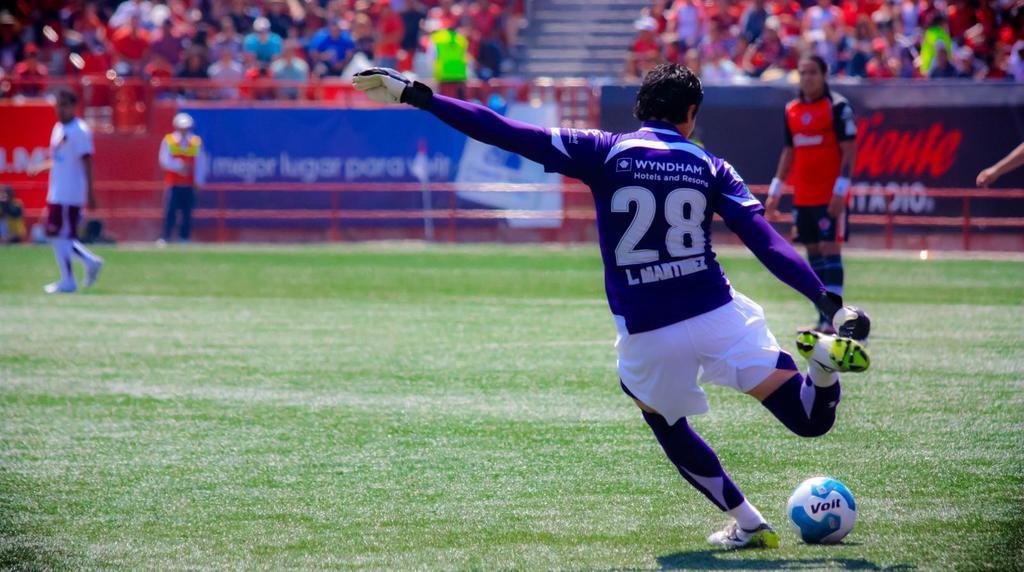Please provide a concise description of this image. In this image I see 3 men who are wearing jerseys and I see that this man is wearing gloves and I see a ball over here which is of white and blue in color and I see a word written and I see the green grass. In the background I see number of people in which most of them are sitting and I see boards on which there are words written and I see that it is totally blurred in the background. 